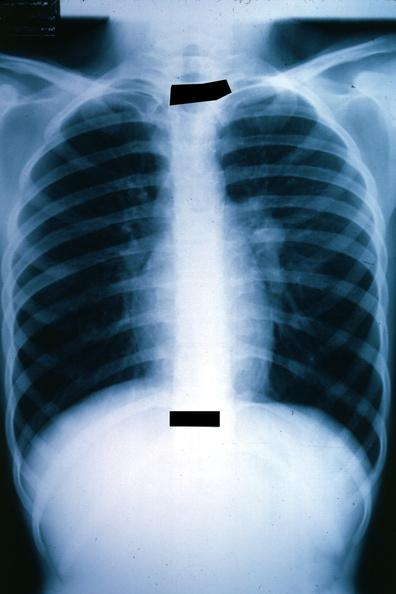what does this image show?
Answer the question using a single word or phrase. X-ray chest well shown left hilar mass tumor in hilar node 